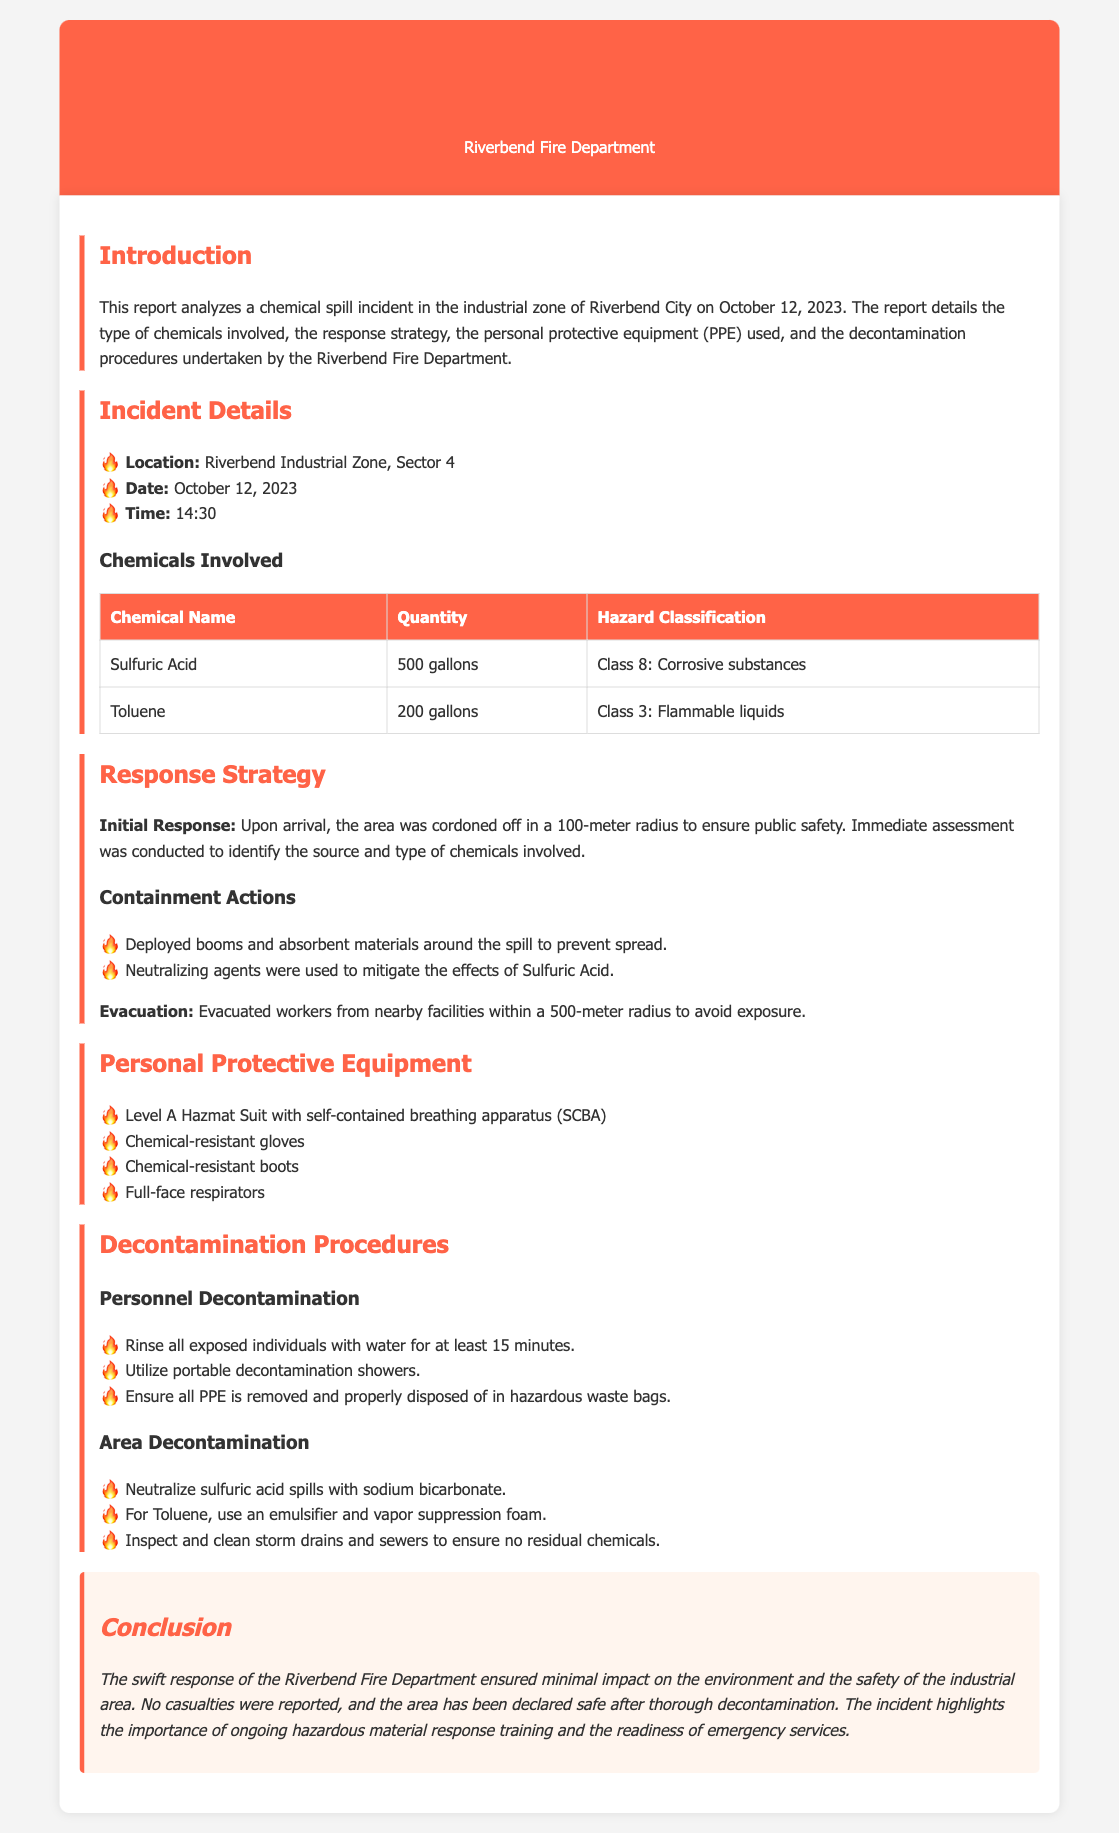What date did the chemical spill occur? The date of the incident is explicitly mentioned in the document as October 12, 2023.
Answer: October 12, 2023 What is the quantity of Sulfuric Acid involved? The document specifies that 500 gallons of Sulfuric Acid were involved in the incident.
Answer: 500 gallons What type of protective equipment was used? The document lists several items of personal protective equipment used, including a Level A Hazmat Suit with SCBA.
Answer: Level A Hazmat Suit with SCBA How far was the area cordoned off for safety? The document states that the area was cordoned off in a 100-meter radius to ensure public safety.
Answer: 100-meter radius What hazardous classification does Toluene fall under? The document classifies Toluene as Class 3: Flammable liquids.
Answer: Class 3: Flammable liquids What were the measures taken for area decontamination? The document outlines specific actions taken for area decontamination, including neutralizing sulfuric acid spills with sodium bicarbonate.
Answer: Neutralize sulfuric acid spills with sodium bicarbonate How long should individuals be rinsed during decontamination? The document indicates that individuals should be rinsed for at least 15 minutes during decontamination procedures.
Answer: 15 minutes What was the initial response action taken upon arrival? The initial response action was to cordon off the area and conduct an immediate assessment of the chemicals involved.
Answer: Cordon off the area and conduct an immediate assessment What is the location of the incident? The document specifies the location of the incident as Riverbend Industrial Zone, Sector 4.
Answer: Riverbend Industrial Zone, Sector 4 